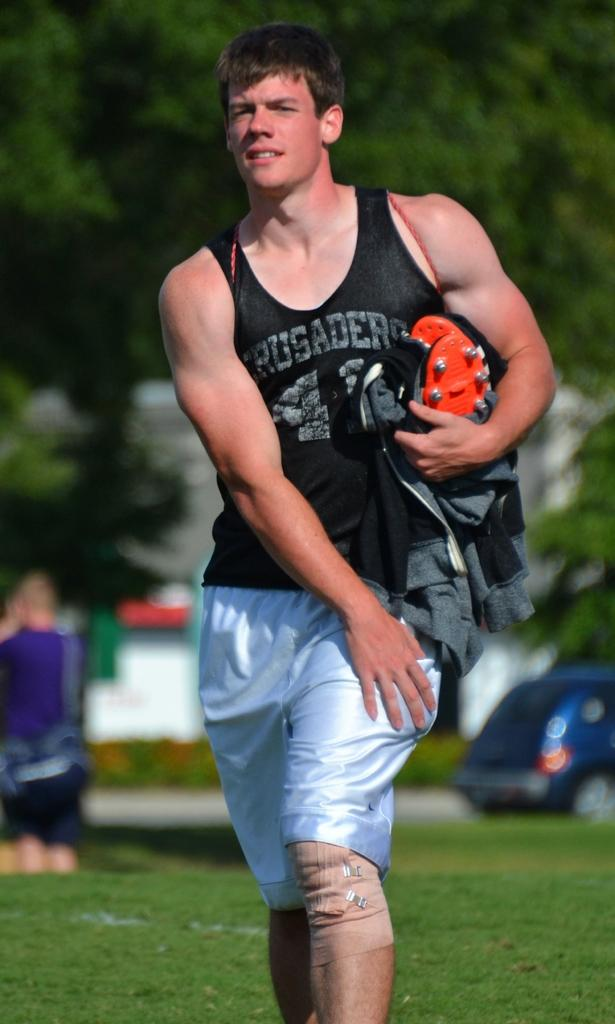Who is the main subject in the image? There is a man in the center of the image. What is the man holding in his hand? The man is holding a coat and another object. What can be seen in the background of the image? There is a vehicle, people, and trees in the background of the image. What type of dinner is being served in the image? There is no dinner present in the image. Can you tell me the age of the man's grandfather in the image? There is no mention of a grandfather in the image, and the age of the man is not specified. 